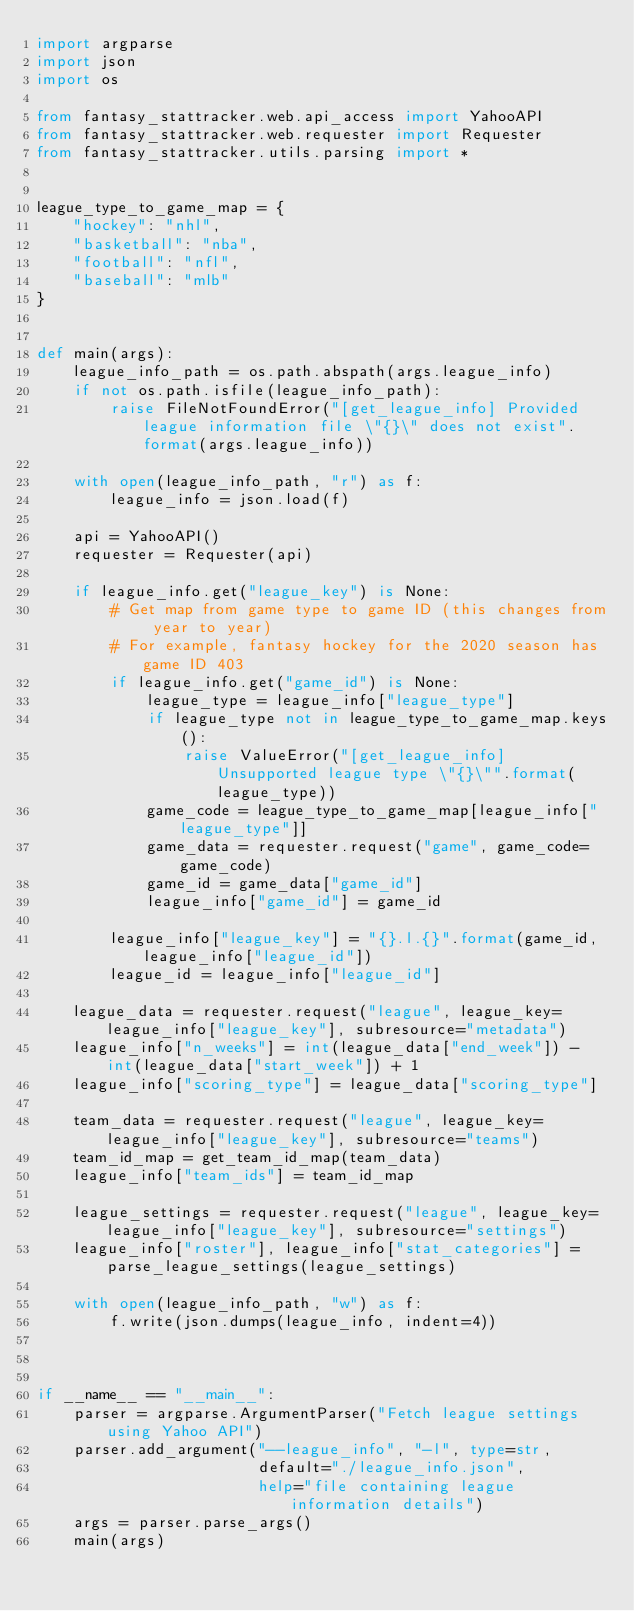Convert code to text. <code><loc_0><loc_0><loc_500><loc_500><_Python_>import argparse
import json
import os

from fantasy_stattracker.web.api_access import YahooAPI
from fantasy_stattracker.web.requester import Requester
from fantasy_stattracker.utils.parsing import *


league_type_to_game_map = {
    "hockey": "nhl",
    "basketball": "nba",
    "football": "nfl",
    "baseball": "mlb"
}


def main(args):
    league_info_path = os.path.abspath(args.league_info)
    if not os.path.isfile(league_info_path):
        raise FileNotFoundError("[get_league_info] Provided league information file \"{}\" does not exist".format(args.league_info))

    with open(league_info_path, "r") as f:
        league_info = json.load(f)

    api = YahooAPI()
    requester = Requester(api)

    if league_info.get("league_key") is None:
        # Get map from game type to game ID (this changes from year to year)
        # For example, fantasy hockey for the 2020 season has game ID 403
        if league_info.get("game_id") is None:
            league_type = league_info["league_type"]
            if league_type not in league_type_to_game_map.keys():
                raise ValueError("[get_league_info] Unsupported league type \"{}\"".format(league_type))
            game_code = league_type_to_game_map[league_info["league_type"]]
            game_data = requester.request("game", game_code=game_code)
            game_id = game_data["game_id"]
            league_info["game_id"] = game_id

        league_info["league_key"] = "{}.l.{}".format(game_id, league_info["league_id"])
        league_id = league_info["league_id"]

    league_data = requester.request("league", league_key=league_info["league_key"], subresource="metadata")
    league_info["n_weeks"] = int(league_data["end_week"]) - int(league_data["start_week"]) + 1
    league_info["scoring_type"] = league_data["scoring_type"]

    team_data = requester.request("league", league_key=league_info["league_key"], subresource="teams")
    team_id_map = get_team_id_map(team_data)
    league_info["team_ids"] = team_id_map

    league_settings = requester.request("league", league_key=league_info["league_key"], subresource="settings")
    league_info["roster"], league_info["stat_categories"] = parse_league_settings(league_settings)

    with open(league_info_path, "w") as f:
        f.write(json.dumps(league_info, indent=4))



if __name__ == "__main__":
    parser = argparse.ArgumentParser("Fetch league settings using Yahoo API")
    parser.add_argument("--league_info", "-l", type=str,
                        default="./league_info.json",
                        help="file containing league information details")
    args = parser.parse_args()
    main(args)</code> 